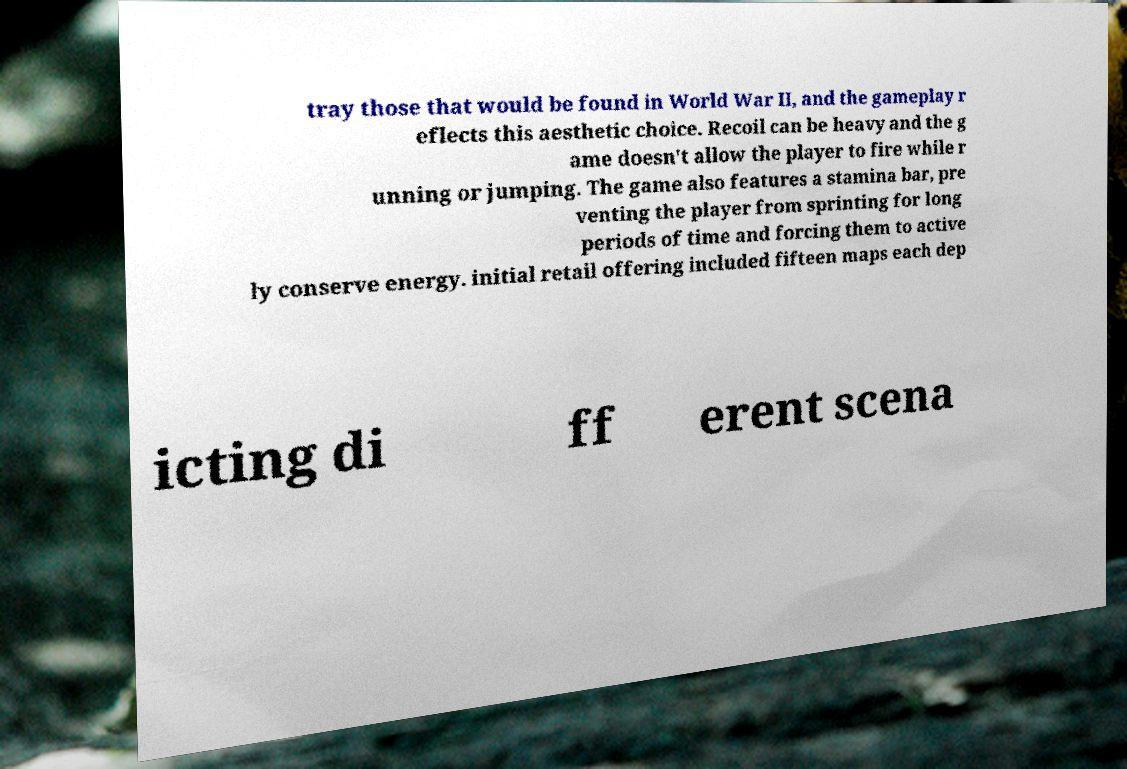Can you read and provide the text displayed in the image?This photo seems to have some interesting text. Can you extract and type it out for me? tray those that would be found in World War II, and the gameplay r eflects this aesthetic choice. Recoil can be heavy and the g ame doesn't allow the player to fire while r unning or jumping. The game also features a stamina bar, pre venting the player from sprinting for long periods of time and forcing them to active ly conserve energy. initial retail offering included fifteen maps each dep icting di ff erent scena 